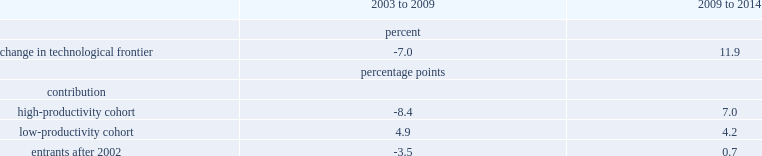What was the percent of the aggregate technological frontier dropped from 2003 to 2009? 7. What was the percentage points of the contributions of the high-productivity cohort? -8.4. What was the percentage points of the contributions of the low-productivity cohort? 4.9. What was the percentage points of the contributions of the new entrants? -3.5. The technological frontier fully recovered after 2009, what was the percentage points of the contributions of the high-productivity cohort? 7.0. The technological frontier fully recovered after 2009, what was the percentage points of the contributions of the low-productivity cohort? 4.2. The technological frontier fully recovered after 2009, what was the percentage points of the contributions of the new entrants? 0.7. What was the percent of the aggregate technological frontier dropped from 2003 to 2009? 7. What was the percentage points of the contributions of the high-productivity cohort? -8.4. What was the percentage points of the contributions of the low-productivity cohort? 4.9. What was the percentage points of the contributions of the new entrants? -3.5. The technological frontier fully recovered after 2009, what was the percentage points of the contributions of the high-productivity cohort? 7.0. The technological frontier fully recovered after 2009, what was the percentage points of the contributions of the low-productivity cohort? 4.2. The technological frontier fully recovered after 2009, what was the percentage points of the contributions of the new entrants? 0.7. 